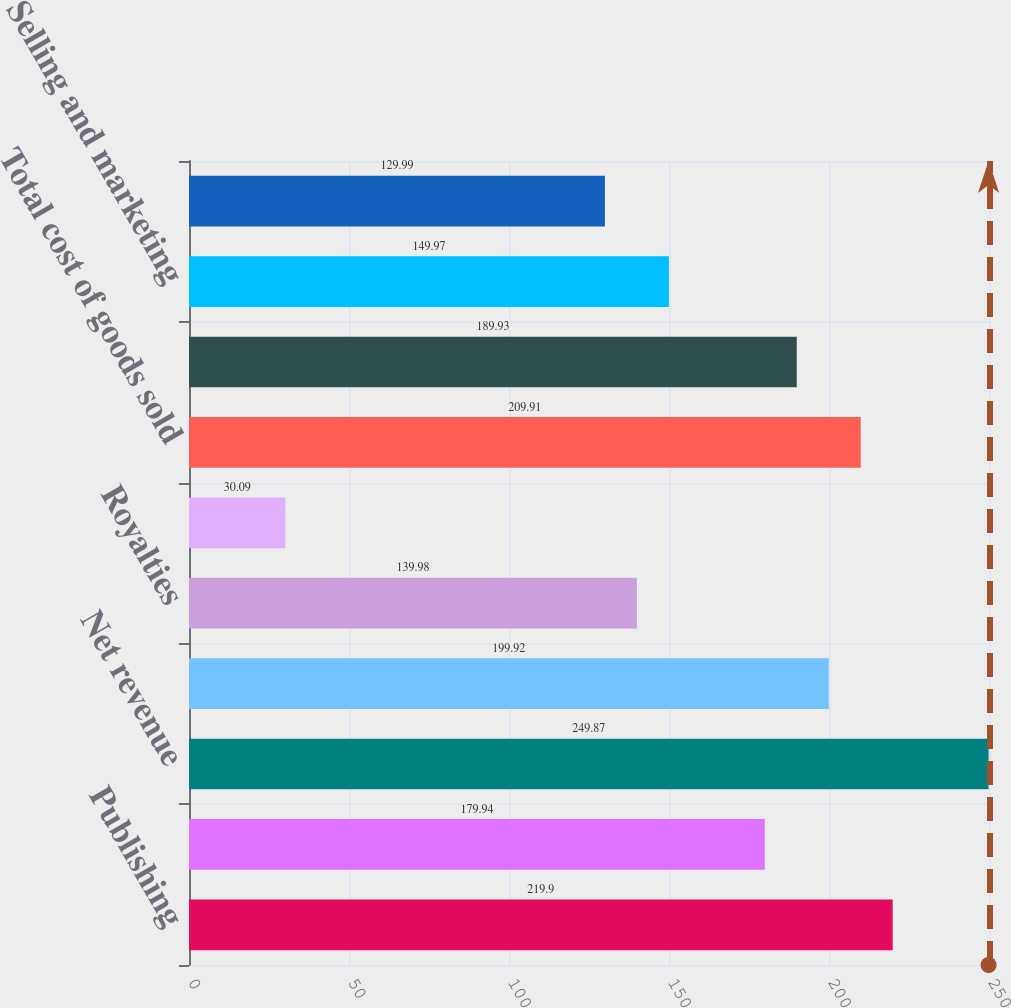Convert chart. <chart><loc_0><loc_0><loc_500><loc_500><bar_chart><fcel>Publishing<fcel>Distribution<fcel>Net revenue<fcel>Product costs<fcel>Royalties<fcel>Software development costs<fcel>Total cost of goods sold<fcel>Gross profit<fcel>Selling and marketing<fcel>General and administrative<nl><fcel>219.9<fcel>179.94<fcel>249.87<fcel>199.92<fcel>139.98<fcel>30.09<fcel>209.91<fcel>189.93<fcel>149.97<fcel>129.99<nl></chart> 